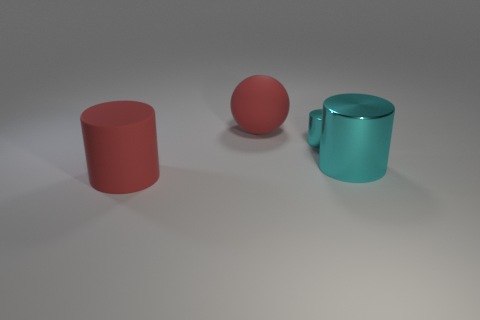Is the shape of the small thing the same as the large cyan thing?
Keep it short and to the point. Yes. Are there fewer big red matte objects in front of the matte sphere than cylinders to the right of the small cyan metal object?
Your response must be concise. No. How many large red rubber things are in front of the matte ball?
Keep it short and to the point. 1. Do the large red rubber thing in front of the rubber ball and the cyan thing that is in front of the tiny object have the same shape?
Keep it short and to the point. Yes. What number of other objects are there of the same color as the sphere?
Offer a very short reply. 1. What material is the big red object that is on the left side of the big red thing to the right of the large red object that is in front of the big metallic object?
Offer a very short reply. Rubber. There is a small thing that is behind the rubber thing in front of the large red matte ball; what is it made of?
Ensure brevity in your answer.  Metal. Are there fewer large balls in front of the big red cylinder than green shiny spheres?
Give a very brief answer. No. The big matte object behind the small cyan thing has what shape?
Your answer should be compact. Sphere. There is a sphere; is it the same size as the metallic object that is right of the tiny cyan metallic object?
Give a very brief answer. Yes. 